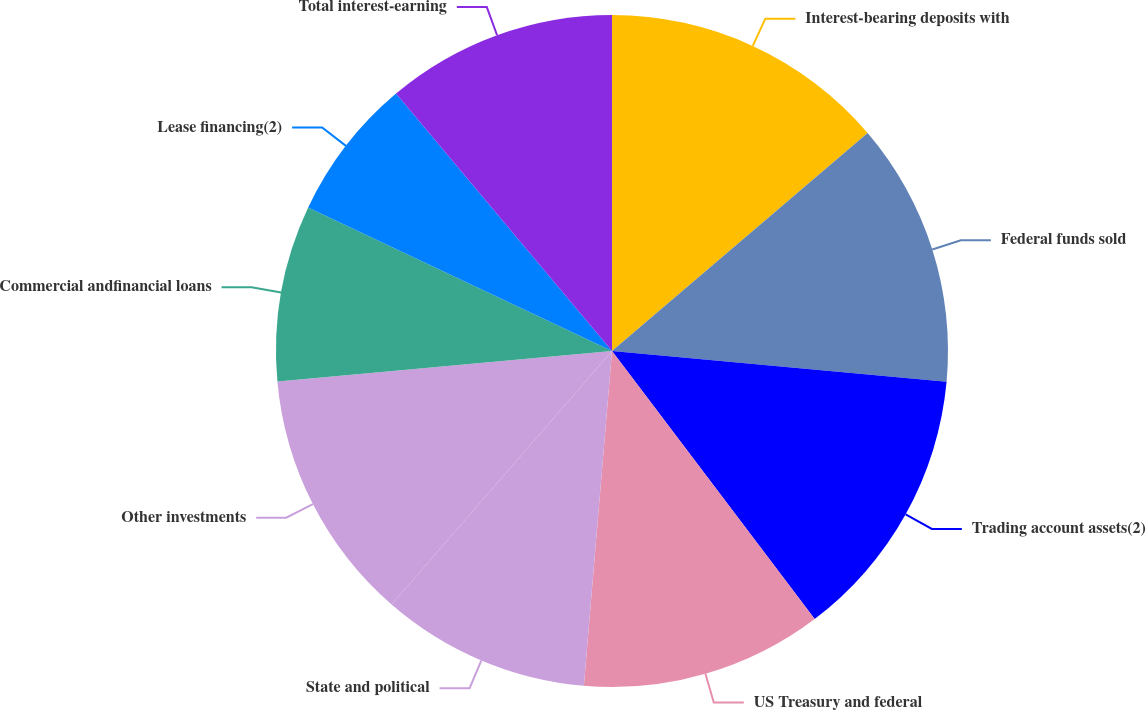<chart> <loc_0><loc_0><loc_500><loc_500><pie_chart><fcel>Interest-bearing deposits with<fcel>Federal funds sold<fcel>Trading account assets(2)<fcel>US Treasury and federal<fcel>State and political<fcel>Other investments<fcel>Commercial andfinancial loans<fcel>Lease financing(2)<fcel>Total interest-earning<nl><fcel>13.76%<fcel>12.7%<fcel>13.23%<fcel>11.64%<fcel>10.05%<fcel>12.17%<fcel>8.46%<fcel>6.87%<fcel>11.11%<nl></chart> 